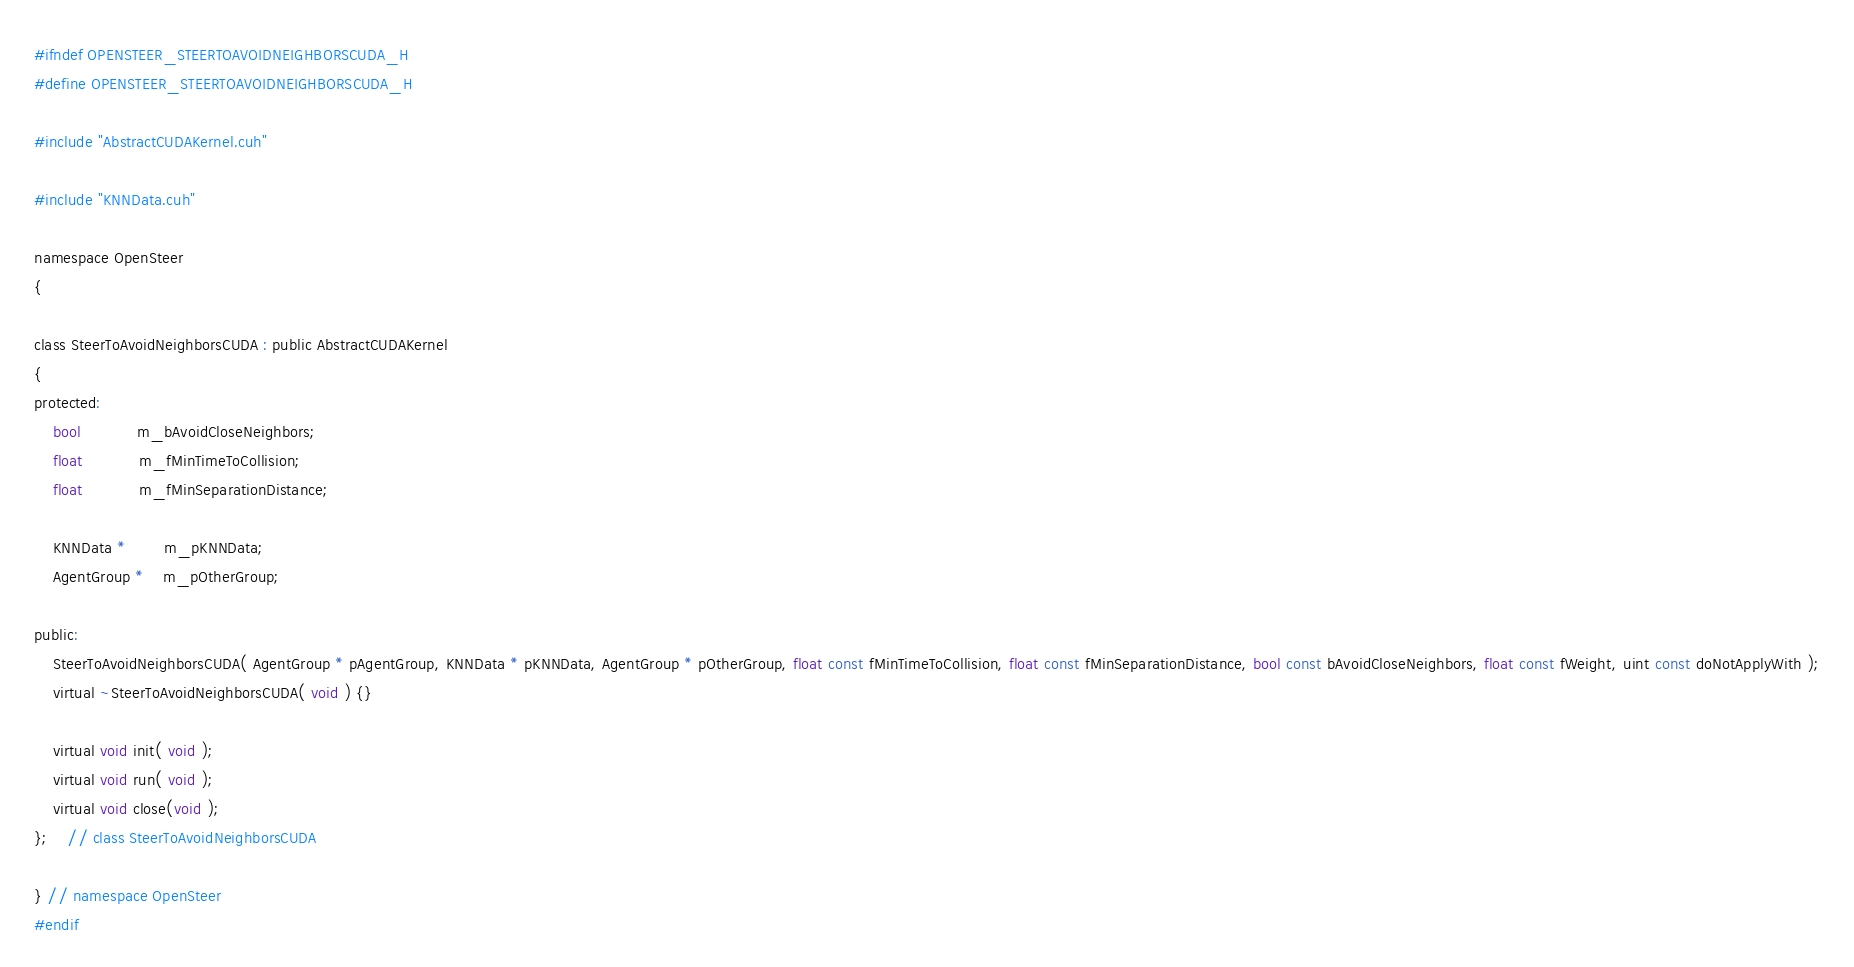<code> <loc_0><loc_0><loc_500><loc_500><_Cuda_>#ifndef OPENSTEER_STEERTOAVOIDNEIGHBORSCUDA_H
#define OPENSTEER_STEERTOAVOIDNEIGHBORSCUDA_H

#include "AbstractCUDAKernel.cuh"

#include "KNNData.cuh"

namespace OpenSteer
{

class SteerToAvoidNeighborsCUDA : public AbstractCUDAKernel
{
protected:
	bool			m_bAvoidCloseNeighbors;
	float			m_fMinTimeToCollision;
	float			m_fMinSeparationDistance;

	KNNData *		m_pKNNData;
	AgentGroup *	m_pOtherGroup;

public:
	SteerToAvoidNeighborsCUDA( AgentGroup * pAgentGroup, KNNData * pKNNData, AgentGroup * pOtherGroup, float const fMinTimeToCollision, float const fMinSeparationDistance, bool const bAvoidCloseNeighbors, float const fWeight, uint const doNotApplyWith );
	virtual ~SteerToAvoidNeighborsCUDA( void ) {}

	virtual void init( void );
	virtual void run( void );
	virtual void close(void );
};	// class SteerToAvoidNeighborsCUDA

} // namespace OpenSteer
#endif</code> 